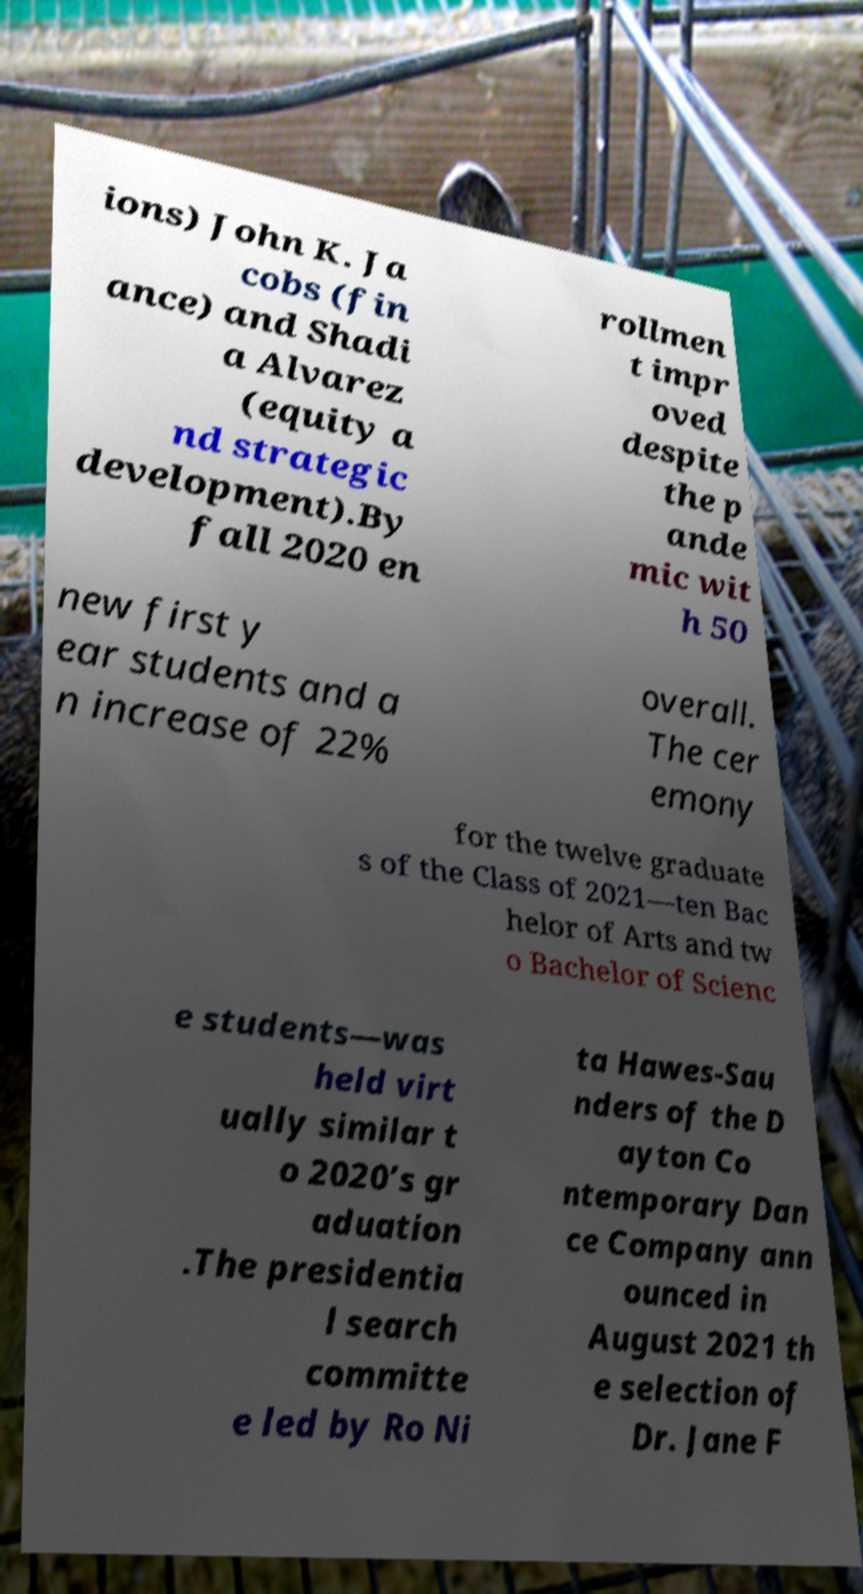Can you read and provide the text displayed in the image?This photo seems to have some interesting text. Can you extract and type it out for me? ions) John K. Ja cobs (fin ance) and Shadi a Alvarez (equity a nd strategic development).By fall 2020 en rollmen t impr oved despite the p ande mic wit h 50 new first y ear students and a n increase of 22% overall. The cer emony for the twelve graduate s of the Class of 2021—ten Bac helor of Arts and tw o Bachelor of Scienc e students—was held virt ually similar t o 2020’s gr aduation .The presidentia l search committe e led by Ro Ni ta Hawes-Sau nders of the D ayton Co ntemporary Dan ce Company ann ounced in August 2021 th e selection of Dr. Jane F 